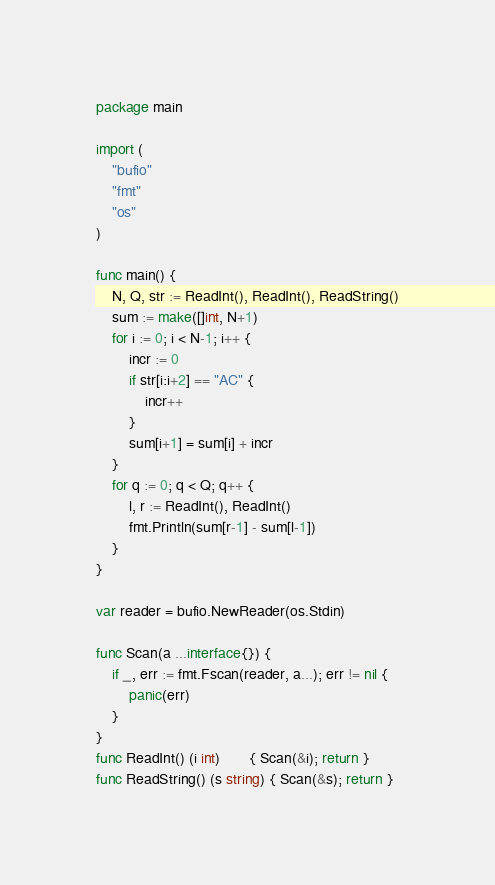<code> <loc_0><loc_0><loc_500><loc_500><_Go_>package main

import (
	"bufio"
	"fmt"
	"os"
)

func main() {
	N, Q, str := ReadInt(), ReadInt(), ReadString()
	sum := make([]int, N+1)
	for i := 0; i < N-1; i++ {
		incr := 0
		if str[i:i+2] == "AC" {
			incr++
		}
		sum[i+1] = sum[i] + incr
	}
	for q := 0; q < Q; q++ {
		l, r := ReadInt(), ReadInt()
		fmt.Println(sum[r-1] - sum[l-1])
	}
}

var reader = bufio.NewReader(os.Stdin)

func Scan(a ...interface{}) {
	if _, err := fmt.Fscan(reader, a...); err != nil {
		panic(err)
	}
}
func ReadInt() (i int)       { Scan(&i); return }
func ReadString() (s string) { Scan(&s); return }
</code> 